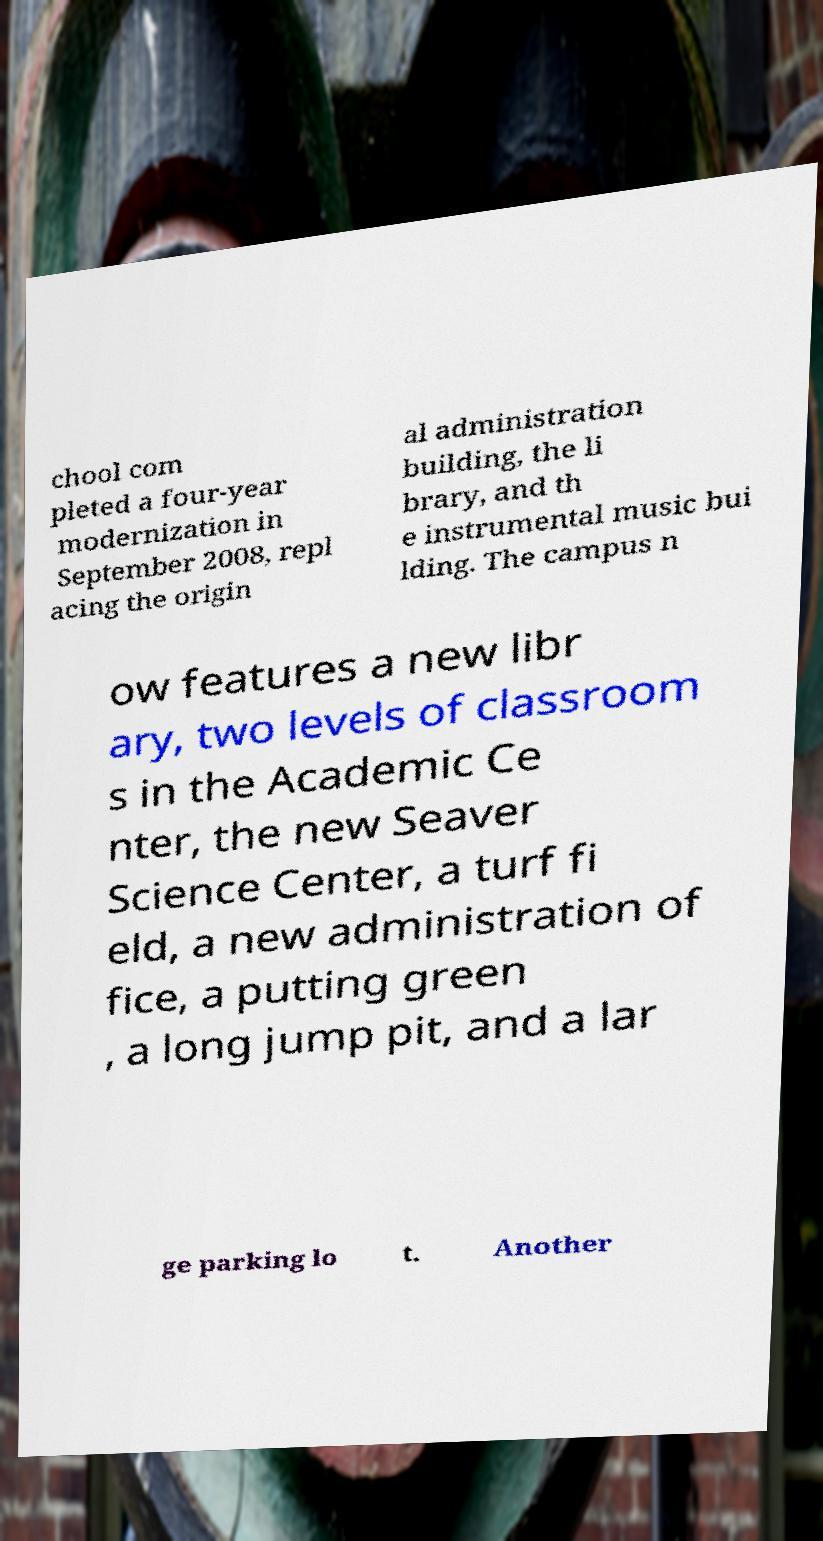Please identify and transcribe the text found in this image. chool com pleted a four-year modernization in September 2008, repl acing the origin al administration building, the li brary, and th e instrumental music bui lding. The campus n ow features a new libr ary, two levels of classroom s in the Academic Ce nter, the new Seaver Science Center, a turf fi eld, a new administration of fice, a putting green , a long jump pit, and a lar ge parking lo t. Another 